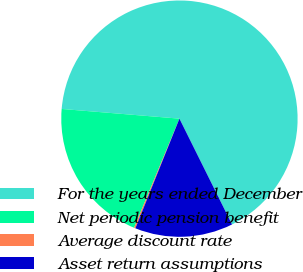Convert chart to OTSL. <chart><loc_0><loc_0><loc_500><loc_500><pie_chart><fcel>For the years ended December<fcel>Net periodic pension benefit<fcel>Average discount rate<fcel>Asset return assumptions<nl><fcel>66.35%<fcel>20.04%<fcel>0.19%<fcel>13.42%<nl></chart> 